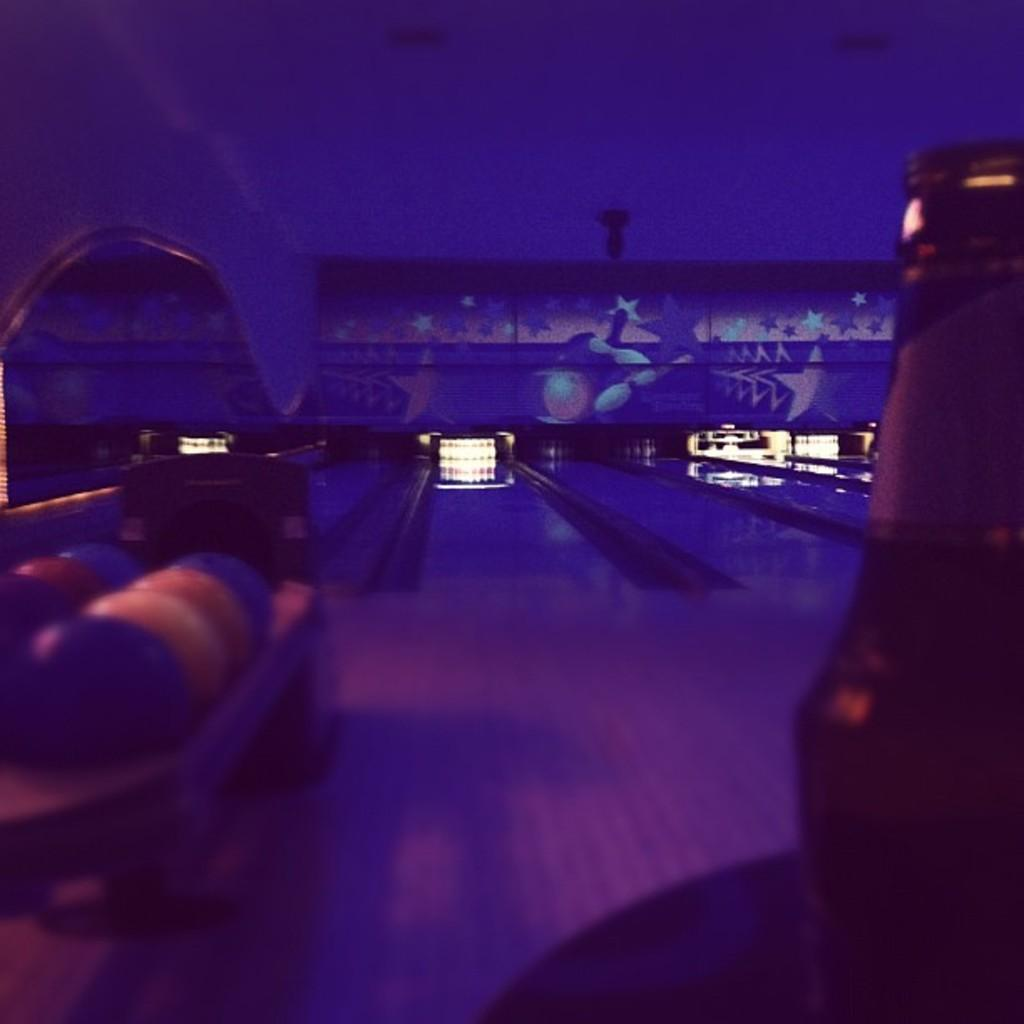What type of location is depicted in the image? The image is taken in a gaming zone. What object can be seen in the front of the image? There is a bottle in the front of the image. Where are the balls located in the image? The balls are on the left side of the image. How many cattle can be seen resting in the gaming zone? There are no cattle present in the image, and the image does not depict any resting animals. 